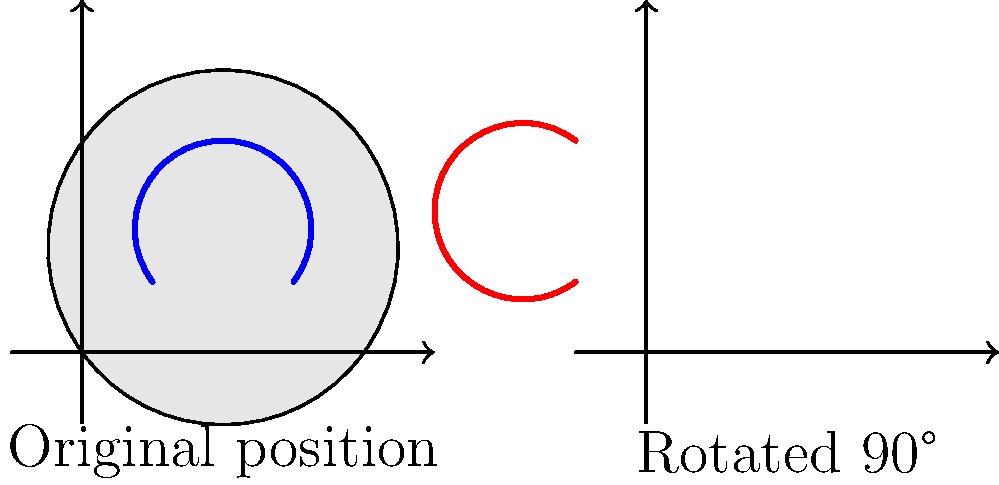As a doula, you're explaining fetal positioning to a client using a simplified diagram. The original fetus diagram is rotated 90 degrees clockwise. If the original fetus's head was positioned at coordinates (0.5, 0.5) and its feet at (1.5, 0.5), what are the new coordinates of the fetus's head and feet after rotation? To solve this problem, we need to apply the principles of 90-degree clockwise rotation in the coordinate plane. Here's a step-by-step explanation:

1) In a 90-degree clockwise rotation, the transformation rule is:
   $$(x, y) \rightarrow (y, -x)$$

2) For the fetus's head:
   Original coordinates: (0.5, 0.5)
   After rotation: (0.5, -0.5)

3) For the fetus's feet:
   Original coordinates: (1.5, 0.5)
   After rotation: (0.5, -1.5)

4) Note that in the rotated position:
   - The y-coordinate of the head becomes the new x-coordinate
   - The negative of the x-coordinate of the head becomes the new y-coordinate
   - The same principle applies to the feet's coordinates

5) The difference in y-coordinates in the rotated position (1 unit) matches the original difference in x-coordinates, preserving the fetus's length.
Answer: Head: (0.5, -0.5), Feet: (0.5, -1.5) 